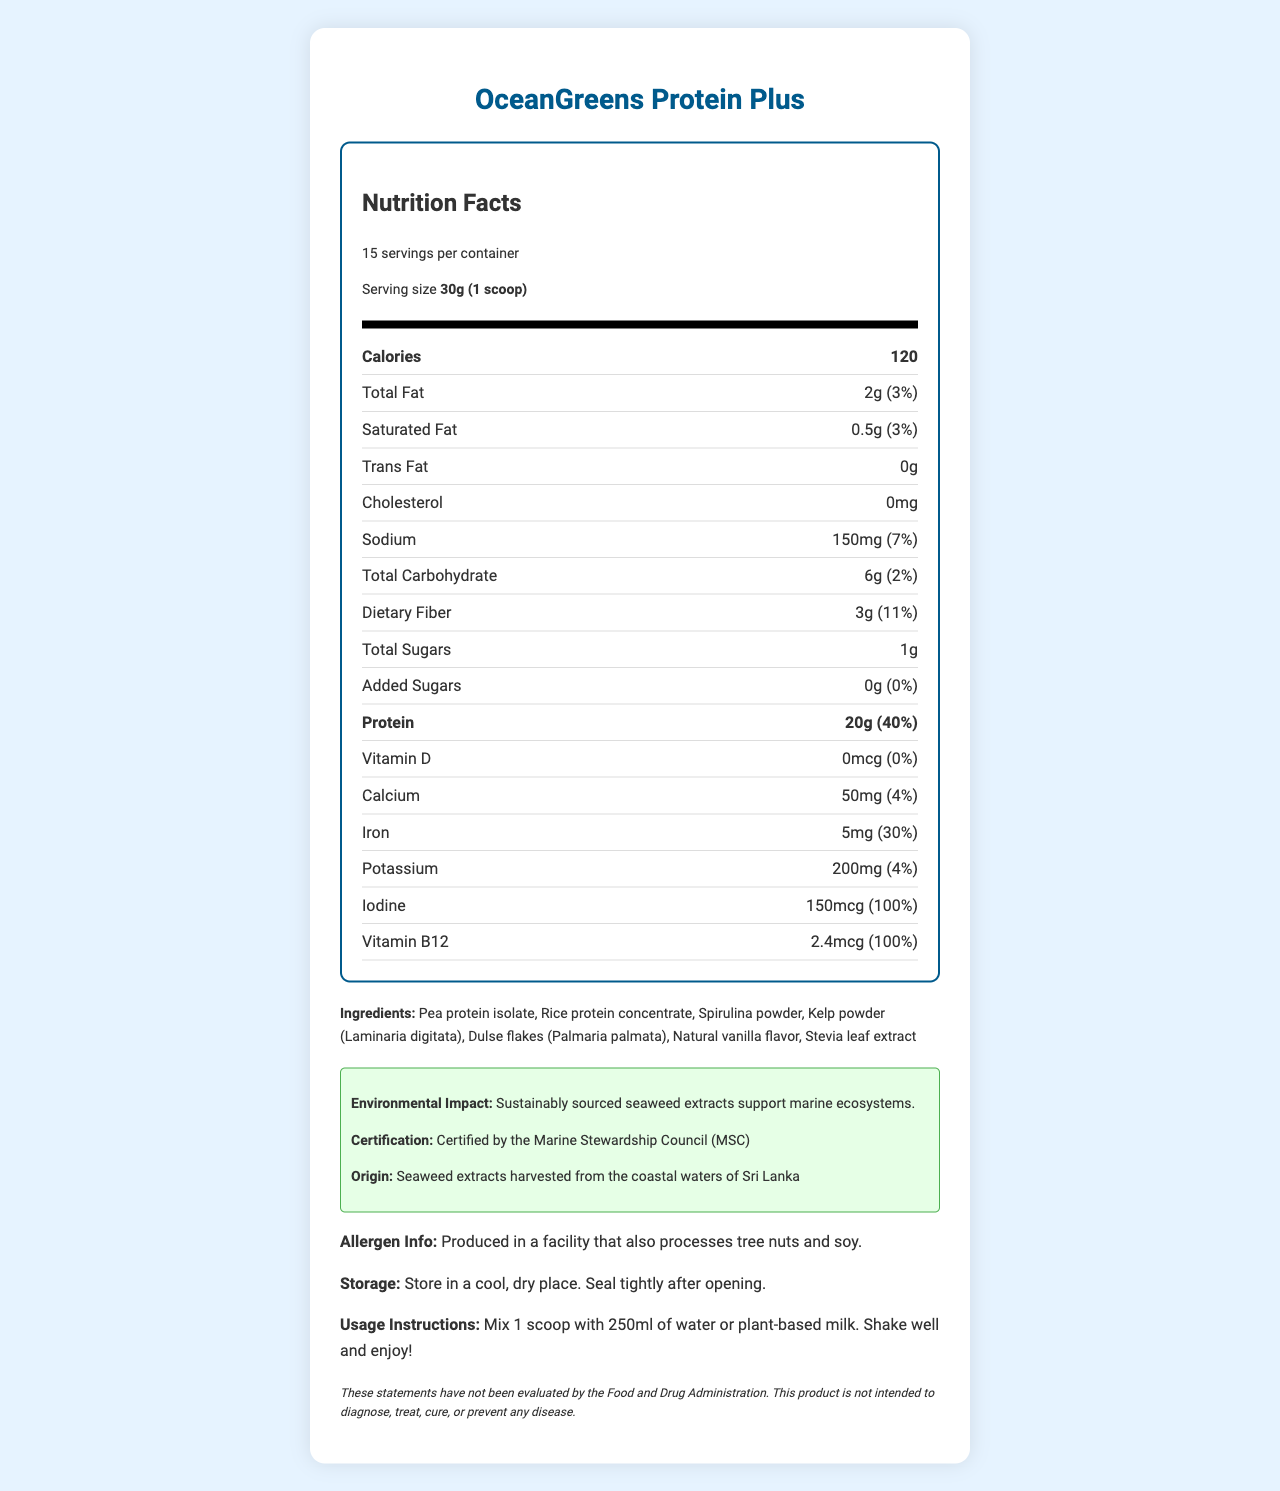What is the serving size for OceanGreens Protein Plus? The serving size is explicitly mentioned as "30g (1 scoop)" in the document.
Answer: 30g (1 scoop) How many calories are there per serving? The document states that each serving contains 120 calories.
Answer: 120 calories How many servings are there per container? The document specifies that there are 15 servings per container.
Answer: 15 servings What is the total amount of protein in one serving? The amount of protein per serving is indicated as 20g in the document.
Answer: 20g List the ingredients of OceanGreens Protein Plus. The document provides a list of ingredients used in the product.
Answer: Pea protein isolate, Rice protein concentrate, Spirulina powder, Kelp powder (Laminaria digitata), Dulse flakes (Palmaria palmata), Natural vanilla flavor, Stevia leaf extract Which vitamin has the highest daily value percentage? A. Vitamin D B. Calcium C. Iron D. Vitamin B12 Vitamin B12 has a daily value of 100%, higher than the other vitamins listed.
Answer: D. Vitamin B12 Which nutrient has the highest percentage Daily Value (DV) per serving? 1. Sodium 2. Iron 3. Potassium 4. Dietary Fiber Iron has a daily value of 30%, which is the highest among the listed nutrients.
Answer: 2. Iron Does OceanGreens Protein Plus contain any added sugars? The document clearly states that the amount of added sugars is 0g, which is also equivalent to 0% of the daily value.
Answer: No Is OceanGreens Protein Plus certified by any organization related to marine sustainability? The document mentions that it is certified by the Marine Stewardship Council (MSC).
Answer: Yes Summarize the primary focus of the OceanGreens Protein Plus nutrition label. The summary covers critical points such as the plant-based nature, nutritional benefits including protein and minerals, and the support for marine sustainability through seaweed extracts and certifications.
Answer: OceanGreens Protein Plus is a plant-based protein powder with added seaweed extracts, promoting high nutritional value, including protein and key minerals, while supporting marine sustainability. What is the total carbohydrate content per serving, including dietary fiber and total sugars? While the document states the total carbohydrate content and individual dietary fiber and total sugars, a combined figure specifically accounting for the dietary fiber and sugars within the carbohydrate content isn't provided.
Answer: Not enough information Explain how the environmental impact is addressed in the document. The environmental impact section of the document emphasizes sustainability efforts, certification by MSC, and the specific source location of seaweed extracts.
Answer: The document states that seaweed extracts are sustainably sourced, supporting marine ecosystems, and the product is certified by the Marine Stewardship Council (MSC). The origin of seaweed extracts is coastal waters of Sri Lanka. What is the iod content in the product, and what percentage of the daily value does it represent? The document lists that iod content is 150mcg, which is 100% of the daily value.
Answer: 150mcg, 100% 